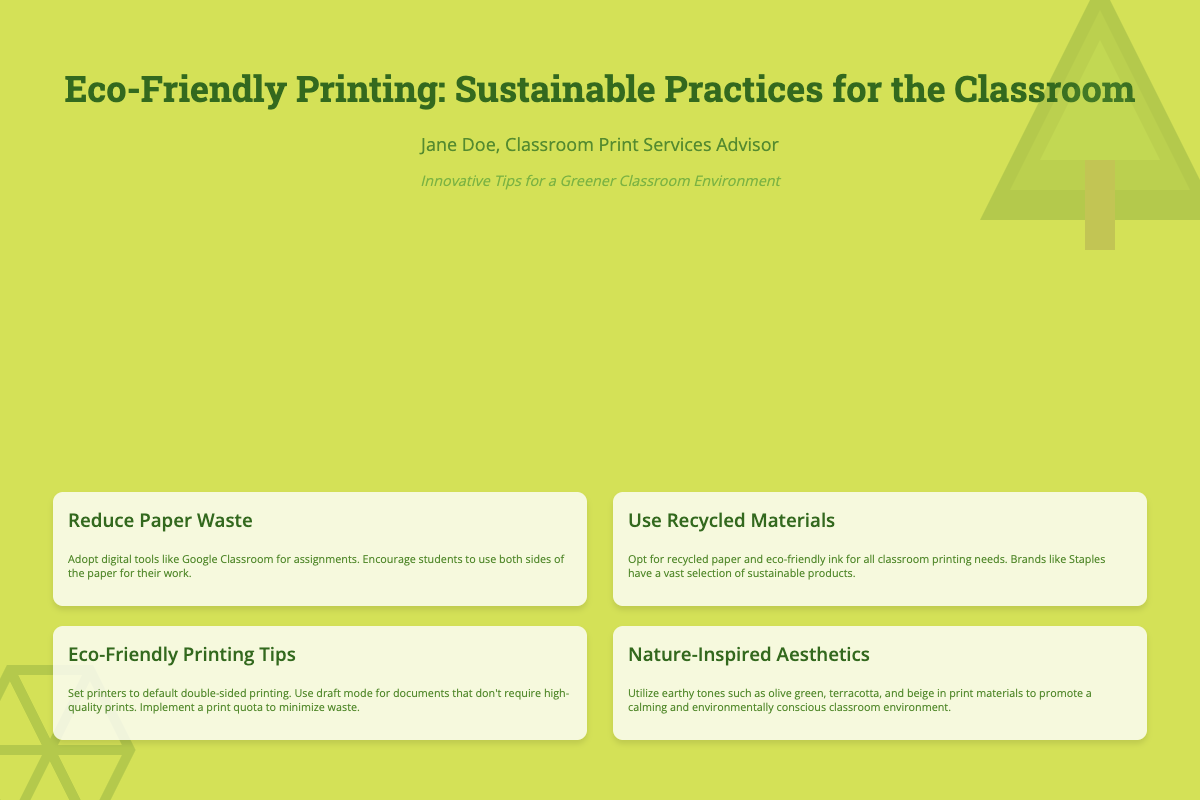What is the title of the book? The title is the main heading of the document, clearly stated at the top.
Answer: Eco-Friendly Printing: Sustainable Practices for the Classroom Who is the author of the book? The author is mentioned directly below the title in the cover.
Answer: Jane Doe, Classroom Print Services Advisor What is the tagline of the book? The tagline provides a brief insight into the book's purpose and is located below the author’s name.
Answer: Innovative Tips for a Greener Classroom Environment What color tones are suggested for print materials? The document suggests specific colors aimed at promoting an aesthetically pleasing classroom environment.
Answer: Earthy tones such as olive green, terracotta, and beige What is one tip for reducing paper waste? The document presents straightforward recommendations for minimizing paper usage.
Answer: Use both sides of the paper for their work What material is recommended for classroom printing needs? The section discusses eco-friendly options to be used in classrooms.
Answer: Recycled paper and eco-friendly ink What printing setting is suggested for documents that don’t require high quality? The document provides a practical recommendation for printing settings.
Answer: Draft mode How can teachers implement a print quota? This question assesses understanding of managing resources better based on the document's information.
Answer: To minimize waste 